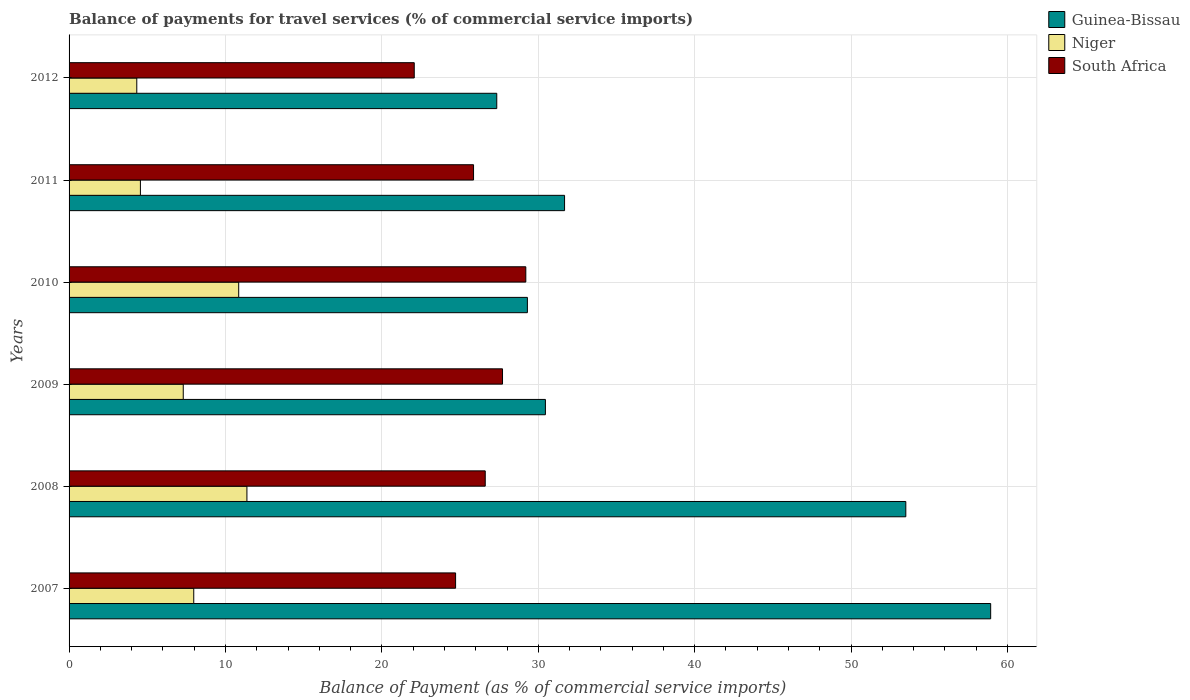Are the number of bars per tick equal to the number of legend labels?
Provide a succinct answer. Yes. Are the number of bars on each tick of the Y-axis equal?
Keep it short and to the point. Yes. In how many cases, is the number of bars for a given year not equal to the number of legend labels?
Your answer should be very brief. 0. What is the balance of payments for travel services in South Africa in 2008?
Offer a terse response. 26.61. Across all years, what is the maximum balance of payments for travel services in Guinea-Bissau?
Give a very brief answer. 58.92. Across all years, what is the minimum balance of payments for travel services in South Africa?
Your answer should be compact. 22.07. In which year was the balance of payments for travel services in Niger maximum?
Your answer should be compact. 2008. What is the total balance of payments for travel services in South Africa in the graph?
Ensure brevity in your answer.  156.17. What is the difference between the balance of payments for travel services in Niger in 2009 and that in 2011?
Provide a succinct answer. 2.74. What is the difference between the balance of payments for travel services in South Africa in 2007 and the balance of payments for travel services in Niger in 2012?
Provide a succinct answer. 20.38. What is the average balance of payments for travel services in Guinea-Bissau per year?
Your answer should be compact. 38.53. In the year 2012, what is the difference between the balance of payments for travel services in Guinea-Bissau and balance of payments for travel services in Niger?
Keep it short and to the point. 23.02. In how many years, is the balance of payments for travel services in South Africa greater than 42 %?
Offer a very short reply. 0. What is the ratio of the balance of payments for travel services in South Africa in 2009 to that in 2011?
Keep it short and to the point. 1.07. Is the balance of payments for travel services in South Africa in 2009 less than that in 2010?
Your response must be concise. Yes. What is the difference between the highest and the second highest balance of payments for travel services in South Africa?
Your answer should be compact. 1.49. What is the difference between the highest and the lowest balance of payments for travel services in Niger?
Your answer should be compact. 7.04. Is the sum of the balance of payments for travel services in Niger in 2009 and 2010 greater than the maximum balance of payments for travel services in Guinea-Bissau across all years?
Provide a succinct answer. No. What does the 3rd bar from the top in 2010 represents?
Provide a short and direct response. Guinea-Bissau. What does the 2nd bar from the bottom in 2011 represents?
Offer a terse response. Niger. Is it the case that in every year, the sum of the balance of payments for travel services in Niger and balance of payments for travel services in South Africa is greater than the balance of payments for travel services in Guinea-Bissau?
Provide a short and direct response. No. What is the difference between two consecutive major ticks on the X-axis?
Provide a succinct answer. 10. Does the graph contain any zero values?
Your answer should be very brief. No. Does the graph contain grids?
Provide a succinct answer. Yes. How many legend labels are there?
Offer a terse response. 3. How are the legend labels stacked?
Offer a very short reply. Vertical. What is the title of the graph?
Your answer should be very brief. Balance of payments for travel services (% of commercial service imports). What is the label or title of the X-axis?
Your response must be concise. Balance of Payment (as % of commercial service imports). What is the label or title of the Y-axis?
Make the answer very short. Years. What is the Balance of Payment (as % of commercial service imports) in Guinea-Bissau in 2007?
Your answer should be compact. 58.92. What is the Balance of Payment (as % of commercial service imports) of Niger in 2007?
Provide a succinct answer. 7.97. What is the Balance of Payment (as % of commercial service imports) in South Africa in 2007?
Your answer should be very brief. 24.71. What is the Balance of Payment (as % of commercial service imports) of Guinea-Bissau in 2008?
Offer a very short reply. 53.5. What is the Balance of Payment (as % of commercial service imports) in Niger in 2008?
Your response must be concise. 11.37. What is the Balance of Payment (as % of commercial service imports) of South Africa in 2008?
Ensure brevity in your answer.  26.61. What is the Balance of Payment (as % of commercial service imports) of Guinea-Bissau in 2009?
Your answer should be very brief. 30.46. What is the Balance of Payment (as % of commercial service imports) of Niger in 2009?
Your response must be concise. 7.3. What is the Balance of Payment (as % of commercial service imports) in South Africa in 2009?
Provide a short and direct response. 27.71. What is the Balance of Payment (as % of commercial service imports) of Guinea-Bissau in 2010?
Ensure brevity in your answer.  29.3. What is the Balance of Payment (as % of commercial service imports) in Niger in 2010?
Make the answer very short. 10.85. What is the Balance of Payment (as % of commercial service imports) of South Africa in 2010?
Your answer should be compact. 29.2. What is the Balance of Payment (as % of commercial service imports) in Guinea-Bissau in 2011?
Ensure brevity in your answer.  31.68. What is the Balance of Payment (as % of commercial service imports) of Niger in 2011?
Your response must be concise. 4.56. What is the Balance of Payment (as % of commercial service imports) of South Africa in 2011?
Provide a short and direct response. 25.86. What is the Balance of Payment (as % of commercial service imports) of Guinea-Bissau in 2012?
Give a very brief answer. 27.34. What is the Balance of Payment (as % of commercial service imports) in Niger in 2012?
Ensure brevity in your answer.  4.33. What is the Balance of Payment (as % of commercial service imports) of South Africa in 2012?
Make the answer very short. 22.07. Across all years, what is the maximum Balance of Payment (as % of commercial service imports) in Guinea-Bissau?
Provide a succinct answer. 58.92. Across all years, what is the maximum Balance of Payment (as % of commercial service imports) in Niger?
Give a very brief answer. 11.37. Across all years, what is the maximum Balance of Payment (as % of commercial service imports) in South Africa?
Give a very brief answer. 29.2. Across all years, what is the minimum Balance of Payment (as % of commercial service imports) of Guinea-Bissau?
Your answer should be very brief. 27.34. Across all years, what is the minimum Balance of Payment (as % of commercial service imports) in Niger?
Ensure brevity in your answer.  4.33. Across all years, what is the minimum Balance of Payment (as % of commercial service imports) of South Africa?
Provide a succinct answer. 22.07. What is the total Balance of Payment (as % of commercial service imports) of Guinea-Bissau in the graph?
Offer a terse response. 231.21. What is the total Balance of Payment (as % of commercial service imports) of Niger in the graph?
Provide a short and direct response. 46.38. What is the total Balance of Payment (as % of commercial service imports) of South Africa in the graph?
Your answer should be compact. 156.17. What is the difference between the Balance of Payment (as % of commercial service imports) of Guinea-Bissau in 2007 and that in 2008?
Your answer should be compact. 5.43. What is the difference between the Balance of Payment (as % of commercial service imports) of Niger in 2007 and that in 2008?
Your response must be concise. -3.4. What is the difference between the Balance of Payment (as % of commercial service imports) in South Africa in 2007 and that in 2008?
Provide a succinct answer. -1.9. What is the difference between the Balance of Payment (as % of commercial service imports) of Guinea-Bissau in 2007 and that in 2009?
Offer a very short reply. 28.47. What is the difference between the Balance of Payment (as % of commercial service imports) of Niger in 2007 and that in 2009?
Your answer should be very brief. 0.67. What is the difference between the Balance of Payment (as % of commercial service imports) of South Africa in 2007 and that in 2009?
Keep it short and to the point. -3. What is the difference between the Balance of Payment (as % of commercial service imports) in Guinea-Bissau in 2007 and that in 2010?
Offer a very short reply. 29.62. What is the difference between the Balance of Payment (as % of commercial service imports) in Niger in 2007 and that in 2010?
Offer a very short reply. -2.87. What is the difference between the Balance of Payment (as % of commercial service imports) of South Africa in 2007 and that in 2010?
Provide a short and direct response. -4.49. What is the difference between the Balance of Payment (as % of commercial service imports) in Guinea-Bissau in 2007 and that in 2011?
Offer a terse response. 27.24. What is the difference between the Balance of Payment (as % of commercial service imports) of Niger in 2007 and that in 2011?
Your response must be concise. 3.41. What is the difference between the Balance of Payment (as % of commercial service imports) in South Africa in 2007 and that in 2011?
Provide a succinct answer. -1.15. What is the difference between the Balance of Payment (as % of commercial service imports) of Guinea-Bissau in 2007 and that in 2012?
Offer a terse response. 31.58. What is the difference between the Balance of Payment (as % of commercial service imports) of Niger in 2007 and that in 2012?
Provide a short and direct response. 3.64. What is the difference between the Balance of Payment (as % of commercial service imports) in South Africa in 2007 and that in 2012?
Give a very brief answer. 2.64. What is the difference between the Balance of Payment (as % of commercial service imports) in Guinea-Bissau in 2008 and that in 2009?
Your answer should be very brief. 23.04. What is the difference between the Balance of Payment (as % of commercial service imports) in Niger in 2008 and that in 2009?
Keep it short and to the point. 4.07. What is the difference between the Balance of Payment (as % of commercial service imports) of South Africa in 2008 and that in 2009?
Provide a short and direct response. -1.1. What is the difference between the Balance of Payment (as % of commercial service imports) of Guinea-Bissau in 2008 and that in 2010?
Your answer should be very brief. 24.2. What is the difference between the Balance of Payment (as % of commercial service imports) of Niger in 2008 and that in 2010?
Give a very brief answer. 0.52. What is the difference between the Balance of Payment (as % of commercial service imports) of South Africa in 2008 and that in 2010?
Provide a short and direct response. -2.59. What is the difference between the Balance of Payment (as % of commercial service imports) in Guinea-Bissau in 2008 and that in 2011?
Your answer should be compact. 21.82. What is the difference between the Balance of Payment (as % of commercial service imports) of Niger in 2008 and that in 2011?
Your response must be concise. 6.81. What is the difference between the Balance of Payment (as % of commercial service imports) of South Africa in 2008 and that in 2011?
Make the answer very short. 0.75. What is the difference between the Balance of Payment (as % of commercial service imports) of Guinea-Bissau in 2008 and that in 2012?
Your answer should be very brief. 26.15. What is the difference between the Balance of Payment (as % of commercial service imports) of Niger in 2008 and that in 2012?
Keep it short and to the point. 7.04. What is the difference between the Balance of Payment (as % of commercial service imports) of South Africa in 2008 and that in 2012?
Offer a terse response. 4.54. What is the difference between the Balance of Payment (as % of commercial service imports) of Guinea-Bissau in 2009 and that in 2010?
Your answer should be compact. 1.15. What is the difference between the Balance of Payment (as % of commercial service imports) of Niger in 2009 and that in 2010?
Ensure brevity in your answer.  -3.55. What is the difference between the Balance of Payment (as % of commercial service imports) in South Africa in 2009 and that in 2010?
Your response must be concise. -1.49. What is the difference between the Balance of Payment (as % of commercial service imports) in Guinea-Bissau in 2009 and that in 2011?
Your answer should be compact. -1.22. What is the difference between the Balance of Payment (as % of commercial service imports) of Niger in 2009 and that in 2011?
Your response must be concise. 2.74. What is the difference between the Balance of Payment (as % of commercial service imports) in South Africa in 2009 and that in 2011?
Offer a very short reply. 1.85. What is the difference between the Balance of Payment (as % of commercial service imports) in Guinea-Bissau in 2009 and that in 2012?
Make the answer very short. 3.11. What is the difference between the Balance of Payment (as % of commercial service imports) in Niger in 2009 and that in 2012?
Offer a very short reply. 2.97. What is the difference between the Balance of Payment (as % of commercial service imports) in South Africa in 2009 and that in 2012?
Offer a terse response. 5.64. What is the difference between the Balance of Payment (as % of commercial service imports) in Guinea-Bissau in 2010 and that in 2011?
Offer a very short reply. -2.38. What is the difference between the Balance of Payment (as % of commercial service imports) of Niger in 2010 and that in 2011?
Offer a very short reply. 6.28. What is the difference between the Balance of Payment (as % of commercial service imports) of South Africa in 2010 and that in 2011?
Your answer should be compact. 3.34. What is the difference between the Balance of Payment (as % of commercial service imports) in Guinea-Bissau in 2010 and that in 2012?
Make the answer very short. 1.96. What is the difference between the Balance of Payment (as % of commercial service imports) in Niger in 2010 and that in 2012?
Your answer should be very brief. 6.52. What is the difference between the Balance of Payment (as % of commercial service imports) of South Africa in 2010 and that in 2012?
Provide a succinct answer. 7.13. What is the difference between the Balance of Payment (as % of commercial service imports) in Guinea-Bissau in 2011 and that in 2012?
Provide a succinct answer. 4.33. What is the difference between the Balance of Payment (as % of commercial service imports) of Niger in 2011 and that in 2012?
Offer a terse response. 0.23. What is the difference between the Balance of Payment (as % of commercial service imports) in South Africa in 2011 and that in 2012?
Offer a terse response. 3.79. What is the difference between the Balance of Payment (as % of commercial service imports) in Guinea-Bissau in 2007 and the Balance of Payment (as % of commercial service imports) in Niger in 2008?
Provide a succinct answer. 47.55. What is the difference between the Balance of Payment (as % of commercial service imports) in Guinea-Bissau in 2007 and the Balance of Payment (as % of commercial service imports) in South Africa in 2008?
Offer a very short reply. 32.32. What is the difference between the Balance of Payment (as % of commercial service imports) in Niger in 2007 and the Balance of Payment (as % of commercial service imports) in South Africa in 2008?
Make the answer very short. -18.64. What is the difference between the Balance of Payment (as % of commercial service imports) in Guinea-Bissau in 2007 and the Balance of Payment (as % of commercial service imports) in Niger in 2009?
Give a very brief answer. 51.62. What is the difference between the Balance of Payment (as % of commercial service imports) of Guinea-Bissau in 2007 and the Balance of Payment (as % of commercial service imports) of South Africa in 2009?
Offer a terse response. 31.21. What is the difference between the Balance of Payment (as % of commercial service imports) of Niger in 2007 and the Balance of Payment (as % of commercial service imports) of South Africa in 2009?
Provide a short and direct response. -19.74. What is the difference between the Balance of Payment (as % of commercial service imports) in Guinea-Bissau in 2007 and the Balance of Payment (as % of commercial service imports) in Niger in 2010?
Give a very brief answer. 48.08. What is the difference between the Balance of Payment (as % of commercial service imports) in Guinea-Bissau in 2007 and the Balance of Payment (as % of commercial service imports) in South Africa in 2010?
Keep it short and to the point. 29.72. What is the difference between the Balance of Payment (as % of commercial service imports) in Niger in 2007 and the Balance of Payment (as % of commercial service imports) in South Africa in 2010?
Make the answer very short. -21.23. What is the difference between the Balance of Payment (as % of commercial service imports) of Guinea-Bissau in 2007 and the Balance of Payment (as % of commercial service imports) of Niger in 2011?
Your answer should be compact. 54.36. What is the difference between the Balance of Payment (as % of commercial service imports) of Guinea-Bissau in 2007 and the Balance of Payment (as % of commercial service imports) of South Africa in 2011?
Offer a very short reply. 33.06. What is the difference between the Balance of Payment (as % of commercial service imports) of Niger in 2007 and the Balance of Payment (as % of commercial service imports) of South Africa in 2011?
Provide a short and direct response. -17.89. What is the difference between the Balance of Payment (as % of commercial service imports) in Guinea-Bissau in 2007 and the Balance of Payment (as % of commercial service imports) in Niger in 2012?
Offer a terse response. 54.6. What is the difference between the Balance of Payment (as % of commercial service imports) in Guinea-Bissau in 2007 and the Balance of Payment (as % of commercial service imports) in South Africa in 2012?
Provide a short and direct response. 36.86. What is the difference between the Balance of Payment (as % of commercial service imports) of Niger in 2007 and the Balance of Payment (as % of commercial service imports) of South Africa in 2012?
Make the answer very short. -14.1. What is the difference between the Balance of Payment (as % of commercial service imports) of Guinea-Bissau in 2008 and the Balance of Payment (as % of commercial service imports) of Niger in 2009?
Your answer should be very brief. 46.2. What is the difference between the Balance of Payment (as % of commercial service imports) of Guinea-Bissau in 2008 and the Balance of Payment (as % of commercial service imports) of South Africa in 2009?
Your response must be concise. 25.79. What is the difference between the Balance of Payment (as % of commercial service imports) of Niger in 2008 and the Balance of Payment (as % of commercial service imports) of South Africa in 2009?
Give a very brief answer. -16.34. What is the difference between the Balance of Payment (as % of commercial service imports) of Guinea-Bissau in 2008 and the Balance of Payment (as % of commercial service imports) of Niger in 2010?
Provide a succinct answer. 42.65. What is the difference between the Balance of Payment (as % of commercial service imports) in Guinea-Bissau in 2008 and the Balance of Payment (as % of commercial service imports) in South Africa in 2010?
Ensure brevity in your answer.  24.3. What is the difference between the Balance of Payment (as % of commercial service imports) in Niger in 2008 and the Balance of Payment (as % of commercial service imports) in South Africa in 2010?
Offer a terse response. -17.83. What is the difference between the Balance of Payment (as % of commercial service imports) of Guinea-Bissau in 2008 and the Balance of Payment (as % of commercial service imports) of Niger in 2011?
Provide a succinct answer. 48.94. What is the difference between the Balance of Payment (as % of commercial service imports) in Guinea-Bissau in 2008 and the Balance of Payment (as % of commercial service imports) in South Africa in 2011?
Your answer should be compact. 27.64. What is the difference between the Balance of Payment (as % of commercial service imports) in Niger in 2008 and the Balance of Payment (as % of commercial service imports) in South Africa in 2011?
Provide a succinct answer. -14.49. What is the difference between the Balance of Payment (as % of commercial service imports) of Guinea-Bissau in 2008 and the Balance of Payment (as % of commercial service imports) of Niger in 2012?
Keep it short and to the point. 49.17. What is the difference between the Balance of Payment (as % of commercial service imports) of Guinea-Bissau in 2008 and the Balance of Payment (as % of commercial service imports) of South Africa in 2012?
Offer a very short reply. 31.43. What is the difference between the Balance of Payment (as % of commercial service imports) of Niger in 2008 and the Balance of Payment (as % of commercial service imports) of South Africa in 2012?
Make the answer very short. -10.7. What is the difference between the Balance of Payment (as % of commercial service imports) of Guinea-Bissau in 2009 and the Balance of Payment (as % of commercial service imports) of Niger in 2010?
Make the answer very short. 19.61. What is the difference between the Balance of Payment (as % of commercial service imports) in Guinea-Bissau in 2009 and the Balance of Payment (as % of commercial service imports) in South Africa in 2010?
Your response must be concise. 1.25. What is the difference between the Balance of Payment (as % of commercial service imports) of Niger in 2009 and the Balance of Payment (as % of commercial service imports) of South Africa in 2010?
Keep it short and to the point. -21.9. What is the difference between the Balance of Payment (as % of commercial service imports) of Guinea-Bissau in 2009 and the Balance of Payment (as % of commercial service imports) of Niger in 2011?
Your answer should be very brief. 25.89. What is the difference between the Balance of Payment (as % of commercial service imports) of Guinea-Bissau in 2009 and the Balance of Payment (as % of commercial service imports) of South Africa in 2011?
Make the answer very short. 4.59. What is the difference between the Balance of Payment (as % of commercial service imports) in Niger in 2009 and the Balance of Payment (as % of commercial service imports) in South Africa in 2011?
Offer a terse response. -18.56. What is the difference between the Balance of Payment (as % of commercial service imports) of Guinea-Bissau in 2009 and the Balance of Payment (as % of commercial service imports) of Niger in 2012?
Provide a short and direct response. 26.13. What is the difference between the Balance of Payment (as % of commercial service imports) in Guinea-Bissau in 2009 and the Balance of Payment (as % of commercial service imports) in South Africa in 2012?
Keep it short and to the point. 8.39. What is the difference between the Balance of Payment (as % of commercial service imports) in Niger in 2009 and the Balance of Payment (as % of commercial service imports) in South Africa in 2012?
Make the answer very short. -14.77. What is the difference between the Balance of Payment (as % of commercial service imports) of Guinea-Bissau in 2010 and the Balance of Payment (as % of commercial service imports) of Niger in 2011?
Keep it short and to the point. 24.74. What is the difference between the Balance of Payment (as % of commercial service imports) of Guinea-Bissau in 2010 and the Balance of Payment (as % of commercial service imports) of South Africa in 2011?
Your response must be concise. 3.44. What is the difference between the Balance of Payment (as % of commercial service imports) of Niger in 2010 and the Balance of Payment (as % of commercial service imports) of South Africa in 2011?
Keep it short and to the point. -15.01. What is the difference between the Balance of Payment (as % of commercial service imports) of Guinea-Bissau in 2010 and the Balance of Payment (as % of commercial service imports) of Niger in 2012?
Provide a short and direct response. 24.97. What is the difference between the Balance of Payment (as % of commercial service imports) in Guinea-Bissau in 2010 and the Balance of Payment (as % of commercial service imports) in South Africa in 2012?
Make the answer very short. 7.23. What is the difference between the Balance of Payment (as % of commercial service imports) of Niger in 2010 and the Balance of Payment (as % of commercial service imports) of South Africa in 2012?
Offer a very short reply. -11.22. What is the difference between the Balance of Payment (as % of commercial service imports) in Guinea-Bissau in 2011 and the Balance of Payment (as % of commercial service imports) in Niger in 2012?
Provide a succinct answer. 27.35. What is the difference between the Balance of Payment (as % of commercial service imports) of Guinea-Bissau in 2011 and the Balance of Payment (as % of commercial service imports) of South Africa in 2012?
Keep it short and to the point. 9.61. What is the difference between the Balance of Payment (as % of commercial service imports) in Niger in 2011 and the Balance of Payment (as % of commercial service imports) in South Africa in 2012?
Offer a terse response. -17.51. What is the average Balance of Payment (as % of commercial service imports) in Guinea-Bissau per year?
Provide a short and direct response. 38.53. What is the average Balance of Payment (as % of commercial service imports) of Niger per year?
Provide a short and direct response. 7.73. What is the average Balance of Payment (as % of commercial service imports) of South Africa per year?
Provide a short and direct response. 26.03. In the year 2007, what is the difference between the Balance of Payment (as % of commercial service imports) of Guinea-Bissau and Balance of Payment (as % of commercial service imports) of Niger?
Provide a short and direct response. 50.95. In the year 2007, what is the difference between the Balance of Payment (as % of commercial service imports) of Guinea-Bissau and Balance of Payment (as % of commercial service imports) of South Africa?
Offer a terse response. 34.21. In the year 2007, what is the difference between the Balance of Payment (as % of commercial service imports) in Niger and Balance of Payment (as % of commercial service imports) in South Africa?
Your response must be concise. -16.74. In the year 2008, what is the difference between the Balance of Payment (as % of commercial service imports) of Guinea-Bissau and Balance of Payment (as % of commercial service imports) of Niger?
Make the answer very short. 42.13. In the year 2008, what is the difference between the Balance of Payment (as % of commercial service imports) in Guinea-Bissau and Balance of Payment (as % of commercial service imports) in South Africa?
Keep it short and to the point. 26.89. In the year 2008, what is the difference between the Balance of Payment (as % of commercial service imports) of Niger and Balance of Payment (as % of commercial service imports) of South Africa?
Your answer should be compact. -15.24. In the year 2009, what is the difference between the Balance of Payment (as % of commercial service imports) of Guinea-Bissau and Balance of Payment (as % of commercial service imports) of Niger?
Ensure brevity in your answer.  23.16. In the year 2009, what is the difference between the Balance of Payment (as % of commercial service imports) in Guinea-Bissau and Balance of Payment (as % of commercial service imports) in South Africa?
Your response must be concise. 2.74. In the year 2009, what is the difference between the Balance of Payment (as % of commercial service imports) of Niger and Balance of Payment (as % of commercial service imports) of South Africa?
Make the answer very short. -20.41. In the year 2010, what is the difference between the Balance of Payment (as % of commercial service imports) of Guinea-Bissau and Balance of Payment (as % of commercial service imports) of Niger?
Provide a short and direct response. 18.46. In the year 2010, what is the difference between the Balance of Payment (as % of commercial service imports) in Guinea-Bissau and Balance of Payment (as % of commercial service imports) in South Africa?
Offer a terse response. 0.1. In the year 2010, what is the difference between the Balance of Payment (as % of commercial service imports) in Niger and Balance of Payment (as % of commercial service imports) in South Africa?
Provide a short and direct response. -18.36. In the year 2011, what is the difference between the Balance of Payment (as % of commercial service imports) in Guinea-Bissau and Balance of Payment (as % of commercial service imports) in Niger?
Ensure brevity in your answer.  27.12. In the year 2011, what is the difference between the Balance of Payment (as % of commercial service imports) of Guinea-Bissau and Balance of Payment (as % of commercial service imports) of South Africa?
Your response must be concise. 5.82. In the year 2011, what is the difference between the Balance of Payment (as % of commercial service imports) in Niger and Balance of Payment (as % of commercial service imports) in South Africa?
Give a very brief answer. -21.3. In the year 2012, what is the difference between the Balance of Payment (as % of commercial service imports) of Guinea-Bissau and Balance of Payment (as % of commercial service imports) of Niger?
Provide a short and direct response. 23.02. In the year 2012, what is the difference between the Balance of Payment (as % of commercial service imports) of Guinea-Bissau and Balance of Payment (as % of commercial service imports) of South Africa?
Keep it short and to the point. 5.28. In the year 2012, what is the difference between the Balance of Payment (as % of commercial service imports) of Niger and Balance of Payment (as % of commercial service imports) of South Africa?
Your answer should be compact. -17.74. What is the ratio of the Balance of Payment (as % of commercial service imports) in Guinea-Bissau in 2007 to that in 2008?
Provide a succinct answer. 1.1. What is the ratio of the Balance of Payment (as % of commercial service imports) in Niger in 2007 to that in 2008?
Your response must be concise. 0.7. What is the ratio of the Balance of Payment (as % of commercial service imports) of South Africa in 2007 to that in 2008?
Your answer should be compact. 0.93. What is the ratio of the Balance of Payment (as % of commercial service imports) in Guinea-Bissau in 2007 to that in 2009?
Make the answer very short. 1.93. What is the ratio of the Balance of Payment (as % of commercial service imports) of Niger in 2007 to that in 2009?
Your answer should be very brief. 1.09. What is the ratio of the Balance of Payment (as % of commercial service imports) in South Africa in 2007 to that in 2009?
Give a very brief answer. 0.89. What is the ratio of the Balance of Payment (as % of commercial service imports) in Guinea-Bissau in 2007 to that in 2010?
Provide a succinct answer. 2.01. What is the ratio of the Balance of Payment (as % of commercial service imports) of Niger in 2007 to that in 2010?
Offer a very short reply. 0.73. What is the ratio of the Balance of Payment (as % of commercial service imports) of South Africa in 2007 to that in 2010?
Provide a succinct answer. 0.85. What is the ratio of the Balance of Payment (as % of commercial service imports) in Guinea-Bissau in 2007 to that in 2011?
Give a very brief answer. 1.86. What is the ratio of the Balance of Payment (as % of commercial service imports) in Niger in 2007 to that in 2011?
Keep it short and to the point. 1.75. What is the ratio of the Balance of Payment (as % of commercial service imports) of South Africa in 2007 to that in 2011?
Give a very brief answer. 0.96. What is the ratio of the Balance of Payment (as % of commercial service imports) of Guinea-Bissau in 2007 to that in 2012?
Your response must be concise. 2.15. What is the ratio of the Balance of Payment (as % of commercial service imports) of Niger in 2007 to that in 2012?
Provide a short and direct response. 1.84. What is the ratio of the Balance of Payment (as % of commercial service imports) in South Africa in 2007 to that in 2012?
Keep it short and to the point. 1.12. What is the ratio of the Balance of Payment (as % of commercial service imports) in Guinea-Bissau in 2008 to that in 2009?
Keep it short and to the point. 1.76. What is the ratio of the Balance of Payment (as % of commercial service imports) in Niger in 2008 to that in 2009?
Your answer should be very brief. 1.56. What is the ratio of the Balance of Payment (as % of commercial service imports) in South Africa in 2008 to that in 2009?
Your answer should be compact. 0.96. What is the ratio of the Balance of Payment (as % of commercial service imports) of Guinea-Bissau in 2008 to that in 2010?
Give a very brief answer. 1.83. What is the ratio of the Balance of Payment (as % of commercial service imports) of Niger in 2008 to that in 2010?
Provide a short and direct response. 1.05. What is the ratio of the Balance of Payment (as % of commercial service imports) of South Africa in 2008 to that in 2010?
Your answer should be compact. 0.91. What is the ratio of the Balance of Payment (as % of commercial service imports) in Guinea-Bissau in 2008 to that in 2011?
Provide a succinct answer. 1.69. What is the ratio of the Balance of Payment (as % of commercial service imports) of Niger in 2008 to that in 2011?
Offer a terse response. 2.49. What is the ratio of the Balance of Payment (as % of commercial service imports) in South Africa in 2008 to that in 2011?
Keep it short and to the point. 1.03. What is the ratio of the Balance of Payment (as % of commercial service imports) of Guinea-Bissau in 2008 to that in 2012?
Your response must be concise. 1.96. What is the ratio of the Balance of Payment (as % of commercial service imports) in Niger in 2008 to that in 2012?
Provide a succinct answer. 2.63. What is the ratio of the Balance of Payment (as % of commercial service imports) of South Africa in 2008 to that in 2012?
Your response must be concise. 1.21. What is the ratio of the Balance of Payment (as % of commercial service imports) in Guinea-Bissau in 2009 to that in 2010?
Keep it short and to the point. 1.04. What is the ratio of the Balance of Payment (as % of commercial service imports) in Niger in 2009 to that in 2010?
Offer a very short reply. 0.67. What is the ratio of the Balance of Payment (as % of commercial service imports) of South Africa in 2009 to that in 2010?
Your response must be concise. 0.95. What is the ratio of the Balance of Payment (as % of commercial service imports) in Guinea-Bissau in 2009 to that in 2011?
Make the answer very short. 0.96. What is the ratio of the Balance of Payment (as % of commercial service imports) in Niger in 2009 to that in 2011?
Provide a succinct answer. 1.6. What is the ratio of the Balance of Payment (as % of commercial service imports) of South Africa in 2009 to that in 2011?
Give a very brief answer. 1.07. What is the ratio of the Balance of Payment (as % of commercial service imports) of Guinea-Bissau in 2009 to that in 2012?
Offer a terse response. 1.11. What is the ratio of the Balance of Payment (as % of commercial service imports) in Niger in 2009 to that in 2012?
Your answer should be compact. 1.69. What is the ratio of the Balance of Payment (as % of commercial service imports) of South Africa in 2009 to that in 2012?
Make the answer very short. 1.26. What is the ratio of the Balance of Payment (as % of commercial service imports) of Guinea-Bissau in 2010 to that in 2011?
Your answer should be compact. 0.93. What is the ratio of the Balance of Payment (as % of commercial service imports) of Niger in 2010 to that in 2011?
Ensure brevity in your answer.  2.38. What is the ratio of the Balance of Payment (as % of commercial service imports) in South Africa in 2010 to that in 2011?
Offer a very short reply. 1.13. What is the ratio of the Balance of Payment (as % of commercial service imports) of Guinea-Bissau in 2010 to that in 2012?
Provide a succinct answer. 1.07. What is the ratio of the Balance of Payment (as % of commercial service imports) of Niger in 2010 to that in 2012?
Your answer should be compact. 2.51. What is the ratio of the Balance of Payment (as % of commercial service imports) in South Africa in 2010 to that in 2012?
Your answer should be compact. 1.32. What is the ratio of the Balance of Payment (as % of commercial service imports) in Guinea-Bissau in 2011 to that in 2012?
Your answer should be compact. 1.16. What is the ratio of the Balance of Payment (as % of commercial service imports) in Niger in 2011 to that in 2012?
Give a very brief answer. 1.05. What is the ratio of the Balance of Payment (as % of commercial service imports) in South Africa in 2011 to that in 2012?
Offer a terse response. 1.17. What is the difference between the highest and the second highest Balance of Payment (as % of commercial service imports) of Guinea-Bissau?
Offer a very short reply. 5.43. What is the difference between the highest and the second highest Balance of Payment (as % of commercial service imports) in Niger?
Make the answer very short. 0.52. What is the difference between the highest and the second highest Balance of Payment (as % of commercial service imports) of South Africa?
Provide a short and direct response. 1.49. What is the difference between the highest and the lowest Balance of Payment (as % of commercial service imports) in Guinea-Bissau?
Ensure brevity in your answer.  31.58. What is the difference between the highest and the lowest Balance of Payment (as % of commercial service imports) of Niger?
Keep it short and to the point. 7.04. What is the difference between the highest and the lowest Balance of Payment (as % of commercial service imports) of South Africa?
Your response must be concise. 7.13. 